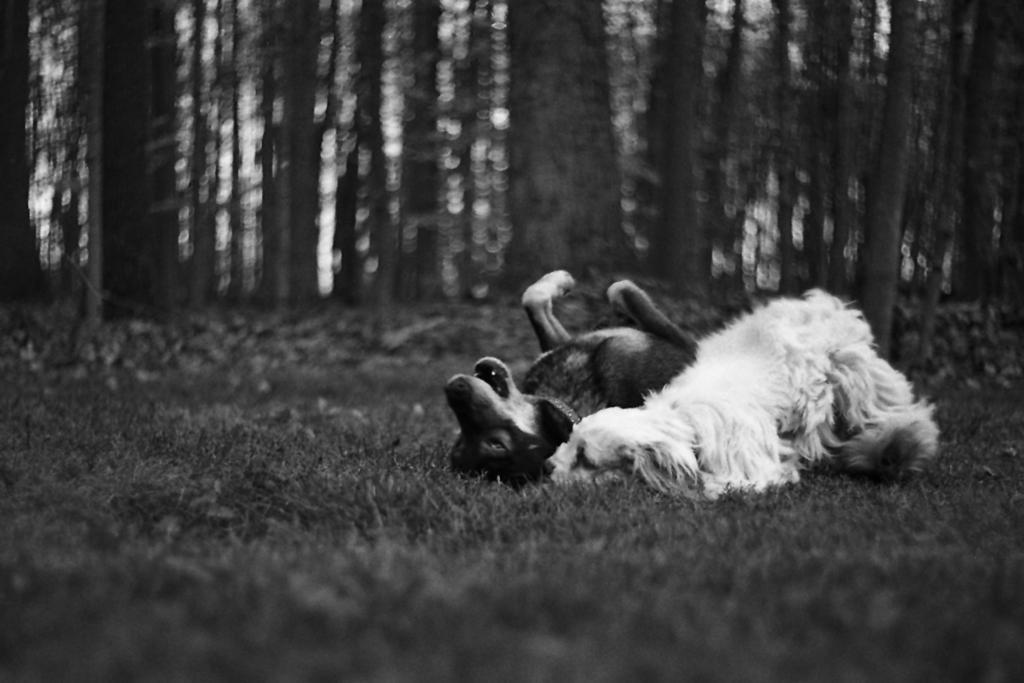How would you summarize this image in a sentence or two? This is the black and white image where we can see two dogs are lying on the grass. The background of the image is blurred, where we can see trees. 